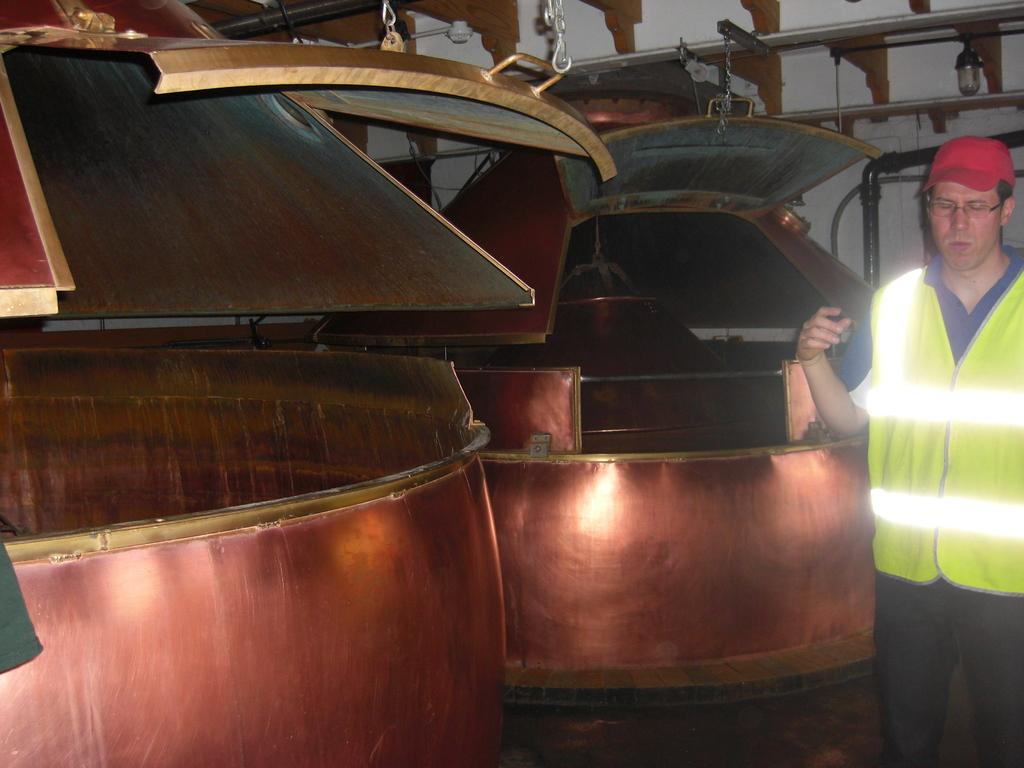What is the main subject of the image? There is a man standing in the image. What objects are located near the man? There are containers beside the man. What feature do the containers have? The containers have hooks attached to them. What can be seen behind the containers? There is a wall visible behind the containers. Can you tell me how many crayons are on the ground in the image? There are no crayons present in the image. Are there any icicles hanging from the wall in the image? There are no icicles visible in the image. 